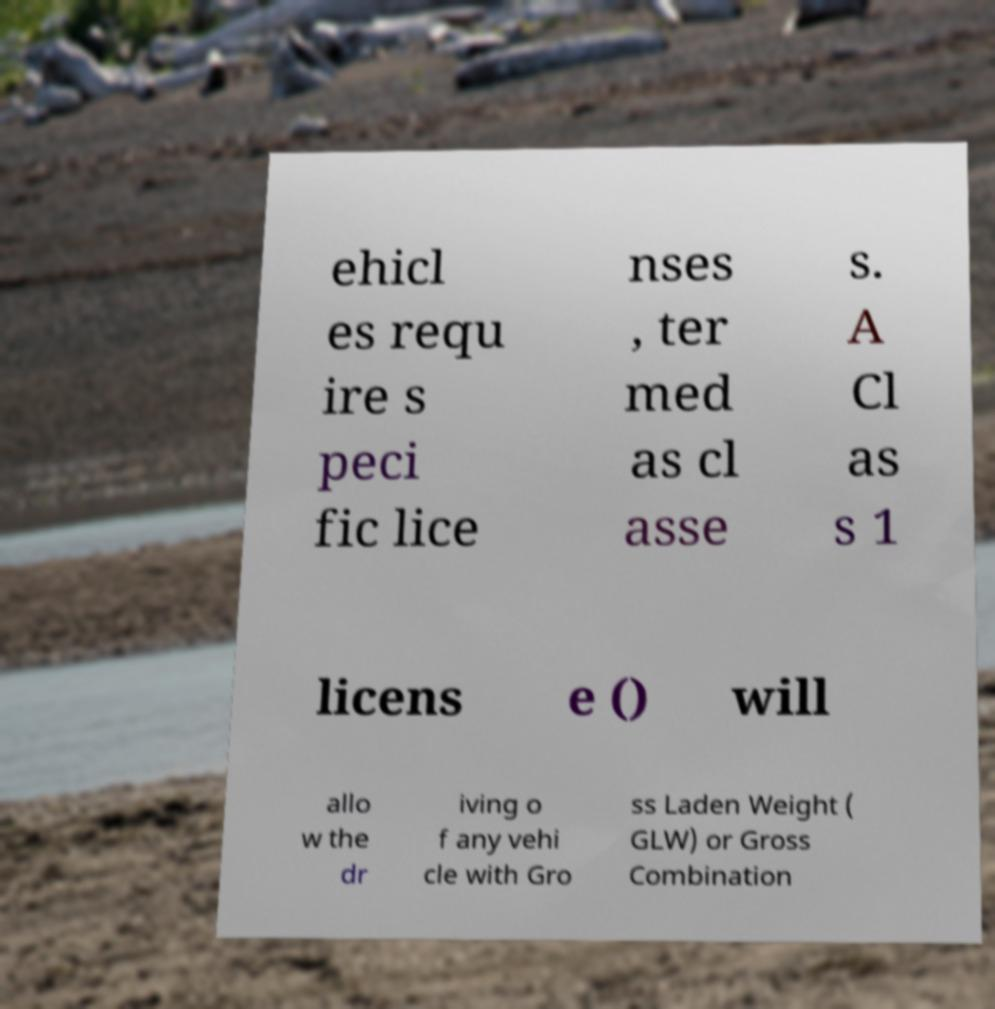I need the written content from this picture converted into text. Can you do that? ehicl es requ ire s peci fic lice nses , ter med as cl asse s. A Cl as s 1 licens e () will allo w the dr iving o f any vehi cle with Gro ss Laden Weight ( GLW) or Gross Combination 